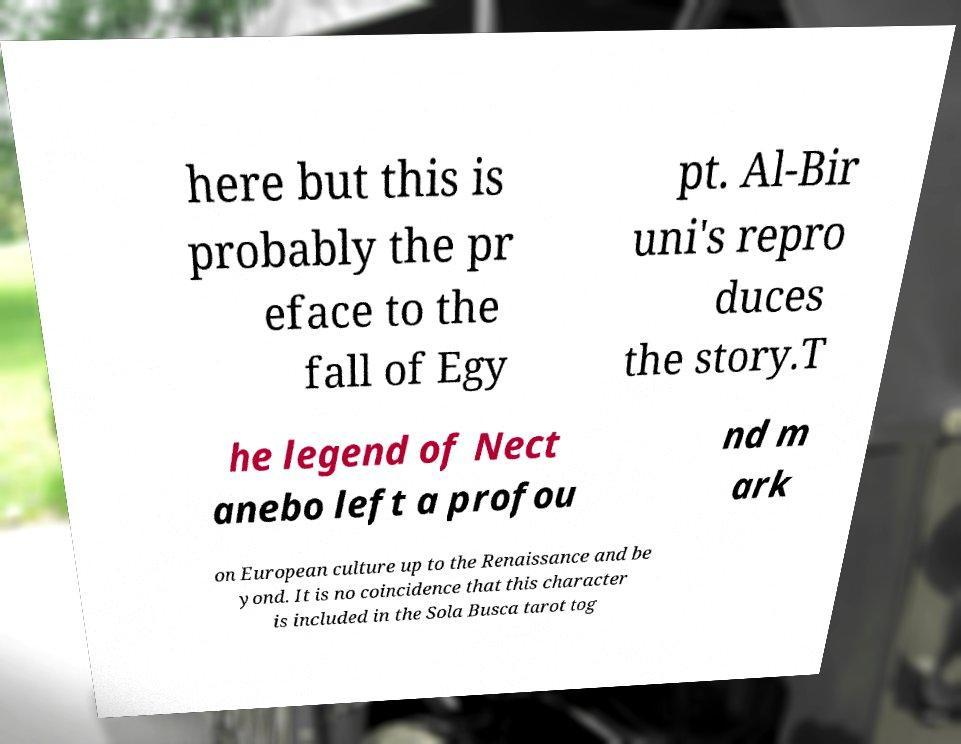For documentation purposes, I need the text within this image transcribed. Could you provide that? here but this is probably the pr eface to the fall of Egy pt. Al-Bir uni's repro duces the story.T he legend of Nect anebo left a profou nd m ark on European culture up to the Renaissance and be yond. It is no coincidence that this character is included in the Sola Busca tarot tog 